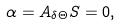Convert formula to latex. <formula><loc_0><loc_0><loc_500><loc_500>\alpha = A _ { \delta \Theta } S = 0 ,</formula> 